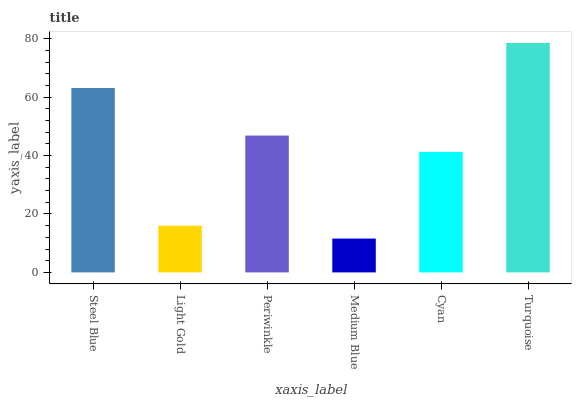Is Medium Blue the minimum?
Answer yes or no. Yes. Is Turquoise the maximum?
Answer yes or no. Yes. Is Light Gold the minimum?
Answer yes or no. No. Is Light Gold the maximum?
Answer yes or no. No. Is Steel Blue greater than Light Gold?
Answer yes or no. Yes. Is Light Gold less than Steel Blue?
Answer yes or no. Yes. Is Light Gold greater than Steel Blue?
Answer yes or no. No. Is Steel Blue less than Light Gold?
Answer yes or no. No. Is Periwinkle the high median?
Answer yes or no. Yes. Is Cyan the low median?
Answer yes or no. Yes. Is Medium Blue the high median?
Answer yes or no. No. Is Periwinkle the low median?
Answer yes or no. No. 